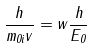Convert formula to latex. <formula><loc_0><loc_0><loc_500><loc_500>\frac { h } { m _ { 0 i } v } = w \frac { h } { E _ { 0 } }</formula> 